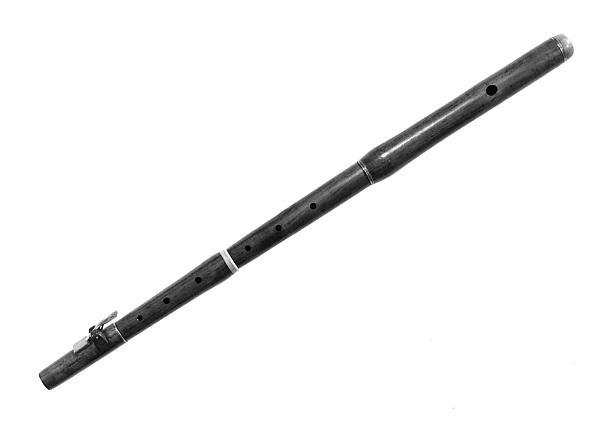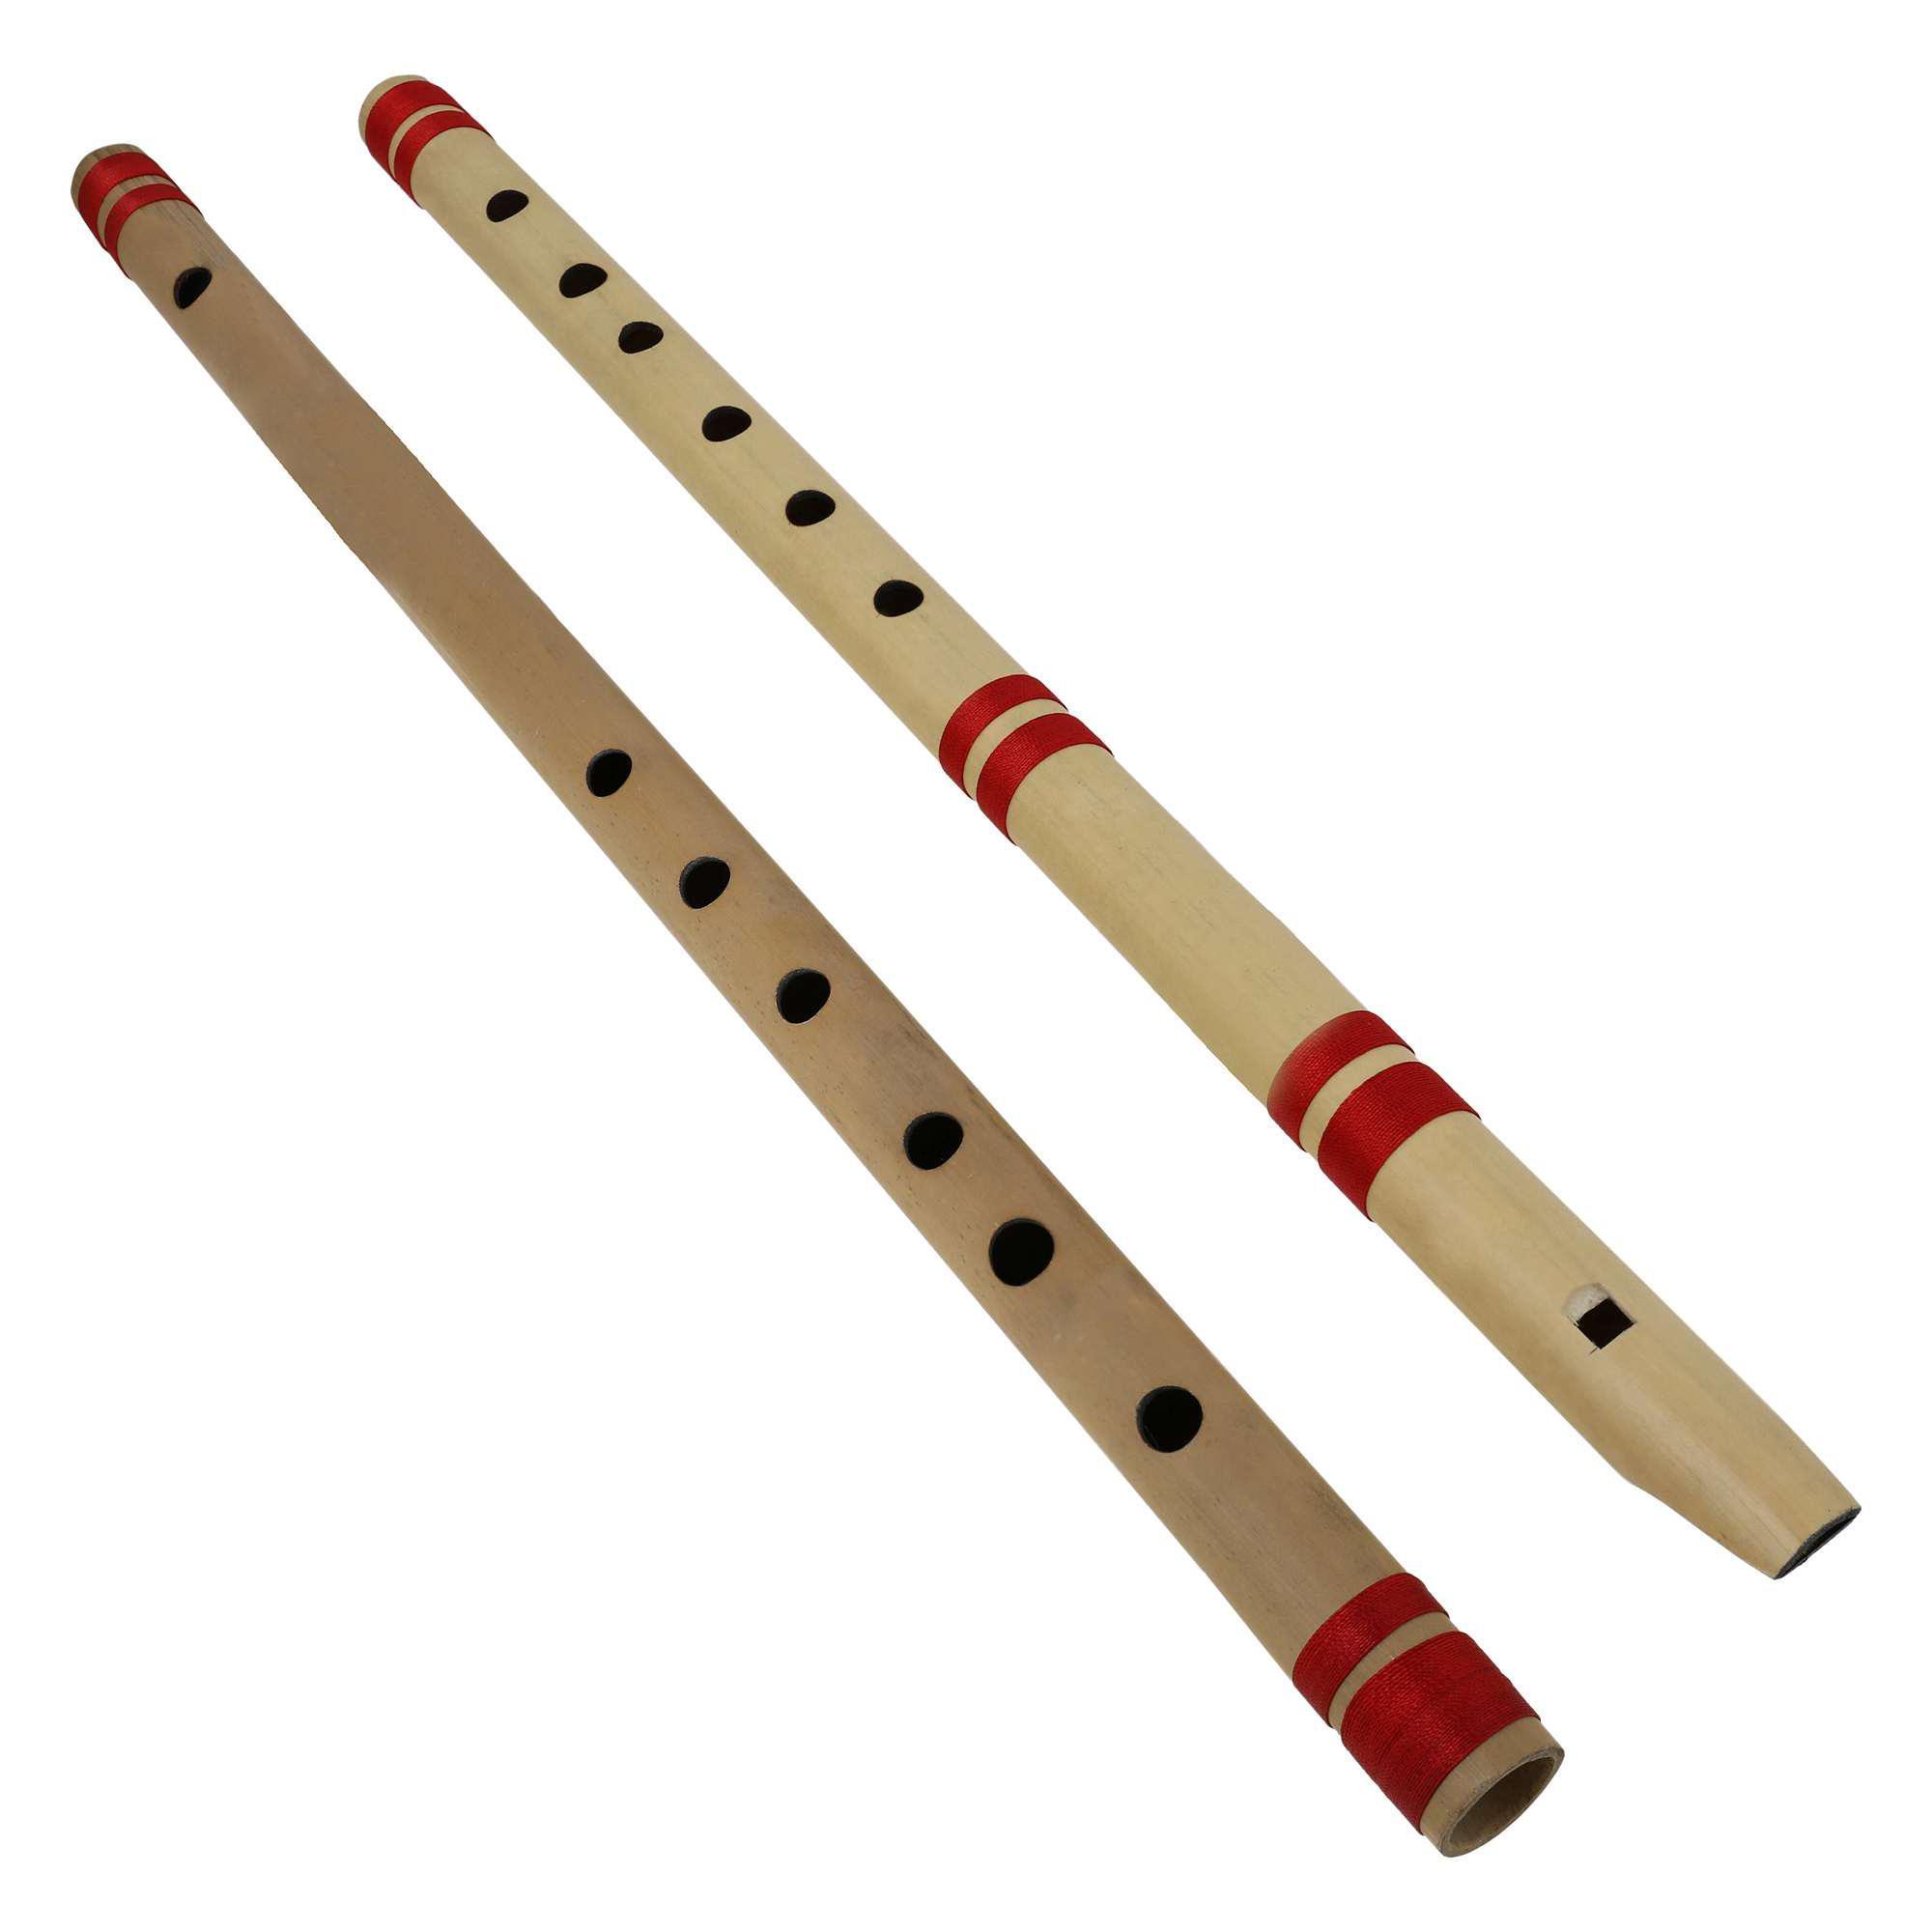The first image is the image on the left, the second image is the image on the right. Analyze the images presented: Is the assertion "One of the instruments is taken apart into two separate pieces." valid? Answer yes or no. No. The first image is the image on the left, the second image is the image on the right. Considering the images on both sides, is "The left image shows two overlapping, criss-crossed flute parts, and the right image shows at least one flute displayed diagonally." valid? Answer yes or no. No. 